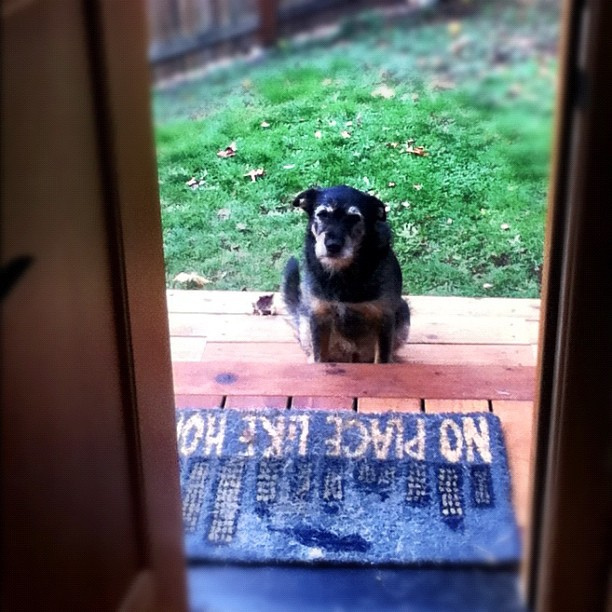Identify the text displayed in this image. HO PIACE ON 